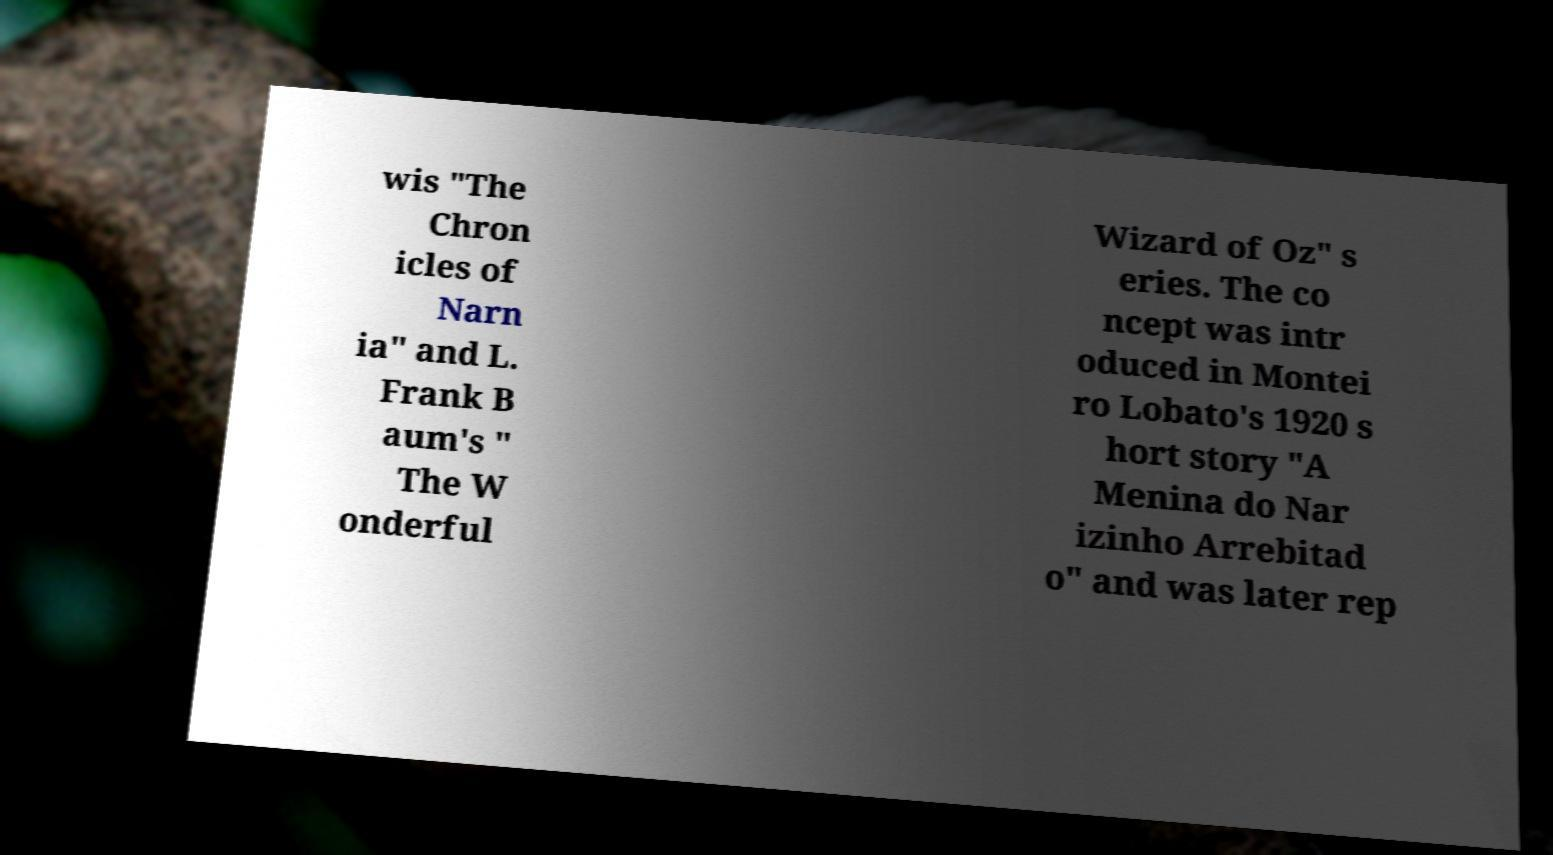Could you extract and type out the text from this image? wis "The Chron icles of Narn ia" and L. Frank B aum's " The W onderful Wizard of Oz" s eries. The co ncept was intr oduced in Montei ro Lobato's 1920 s hort story "A Menina do Nar izinho Arrebitad o" and was later rep 